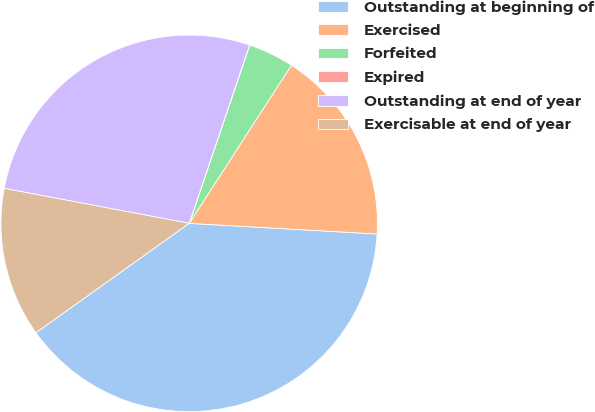<chart> <loc_0><loc_0><loc_500><loc_500><pie_chart><fcel>Outstanding at beginning of<fcel>Exercised<fcel>Forfeited<fcel>Expired<fcel>Outstanding at end of year<fcel>Exercisable at end of year<nl><fcel>39.23%<fcel>16.76%<fcel>3.93%<fcel>0.01%<fcel>27.22%<fcel>12.84%<nl></chart> 